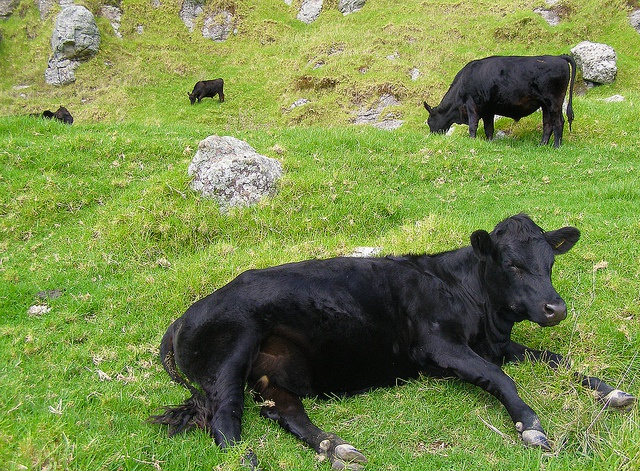Describe the objects in this image and their specific colors. I can see cow in gray, black, and darkgreen tones, cow in gray, black, and darkgreen tones, cow in gray, black, and darkgreen tones, and cow in gray, black, and darkgreen tones in this image. 